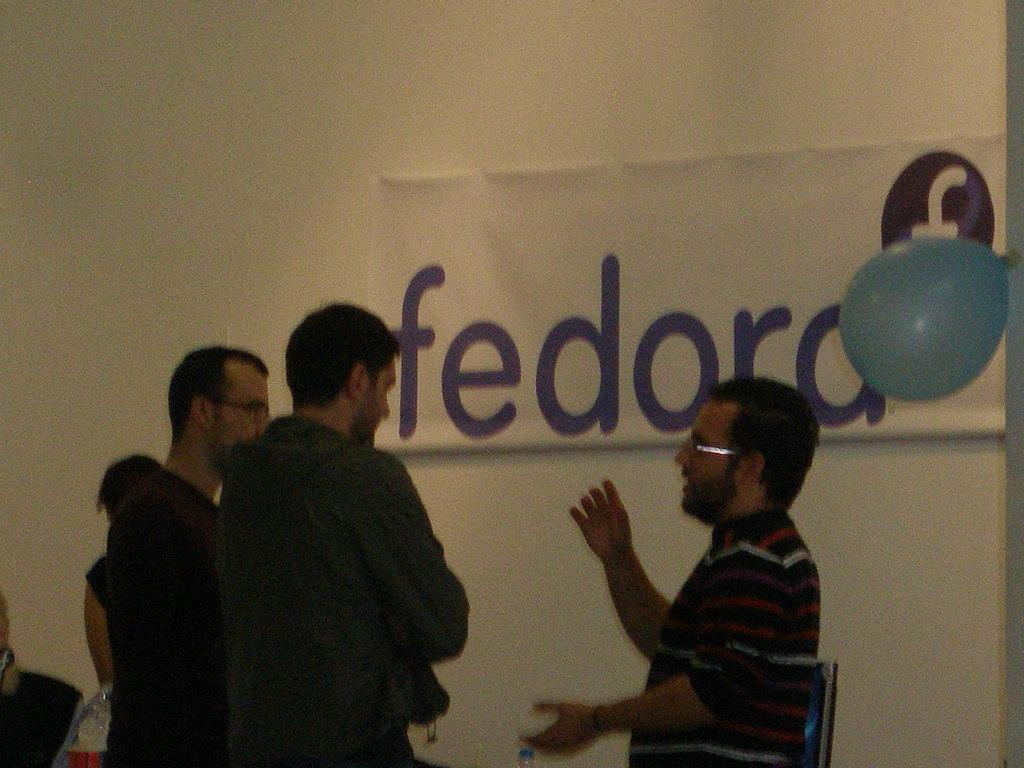How many people are in the image? There is a group of people in the image. What can be seen in the background of the image? There is a monitor and a poster on the wall visible in the background. What is located on the right side of the image? There is a balloon on the right side of the image. How does the beggar in the image ask for money? There is no beggar present in the image. What is the temperature in the room where the image was taken? The provided facts do not mention the temperature or any information about the room's environment. 